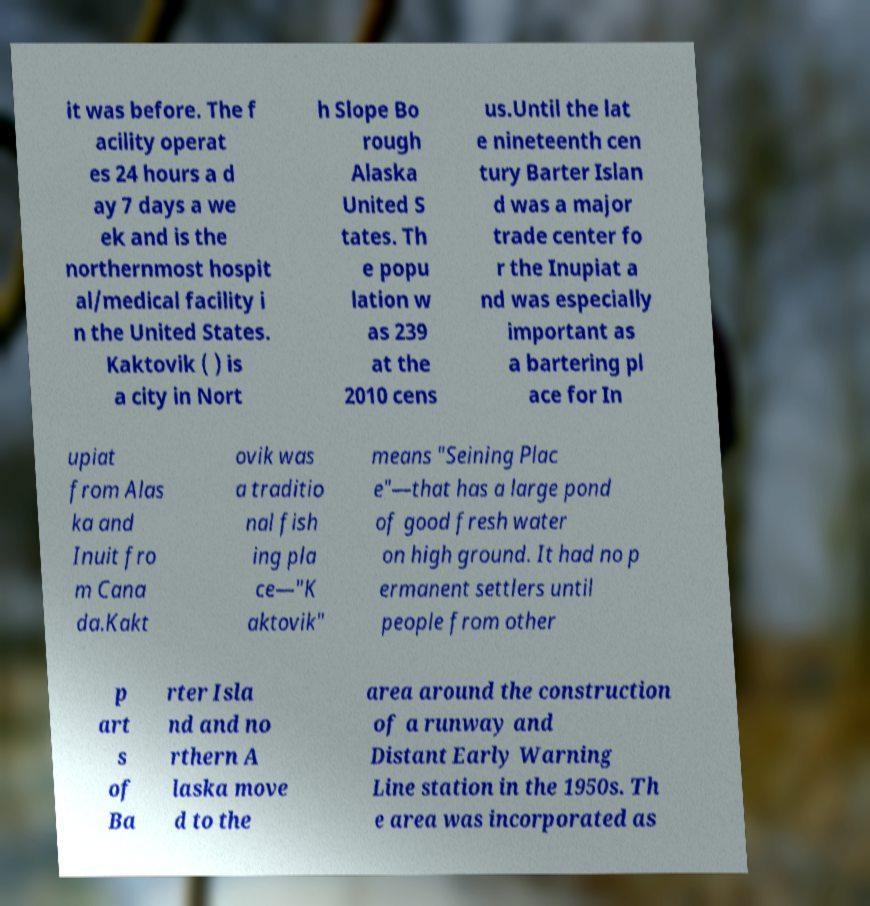What messages or text are displayed in this image? I need them in a readable, typed format. it was before. The f acility operat es 24 hours a d ay 7 days a we ek and is the northernmost hospit al/medical facility i n the United States. Kaktovik ( ) is a city in Nort h Slope Bo rough Alaska United S tates. Th e popu lation w as 239 at the 2010 cens us.Until the lat e nineteenth cen tury Barter Islan d was a major trade center fo r the Inupiat a nd was especially important as a bartering pl ace for In upiat from Alas ka and Inuit fro m Cana da.Kakt ovik was a traditio nal fish ing pla ce—"K aktovik" means "Seining Plac e"—that has a large pond of good fresh water on high ground. It had no p ermanent settlers until people from other p art s of Ba rter Isla nd and no rthern A laska move d to the area around the construction of a runway and Distant Early Warning Line station in the 1950s. Th e area was incorporated as 